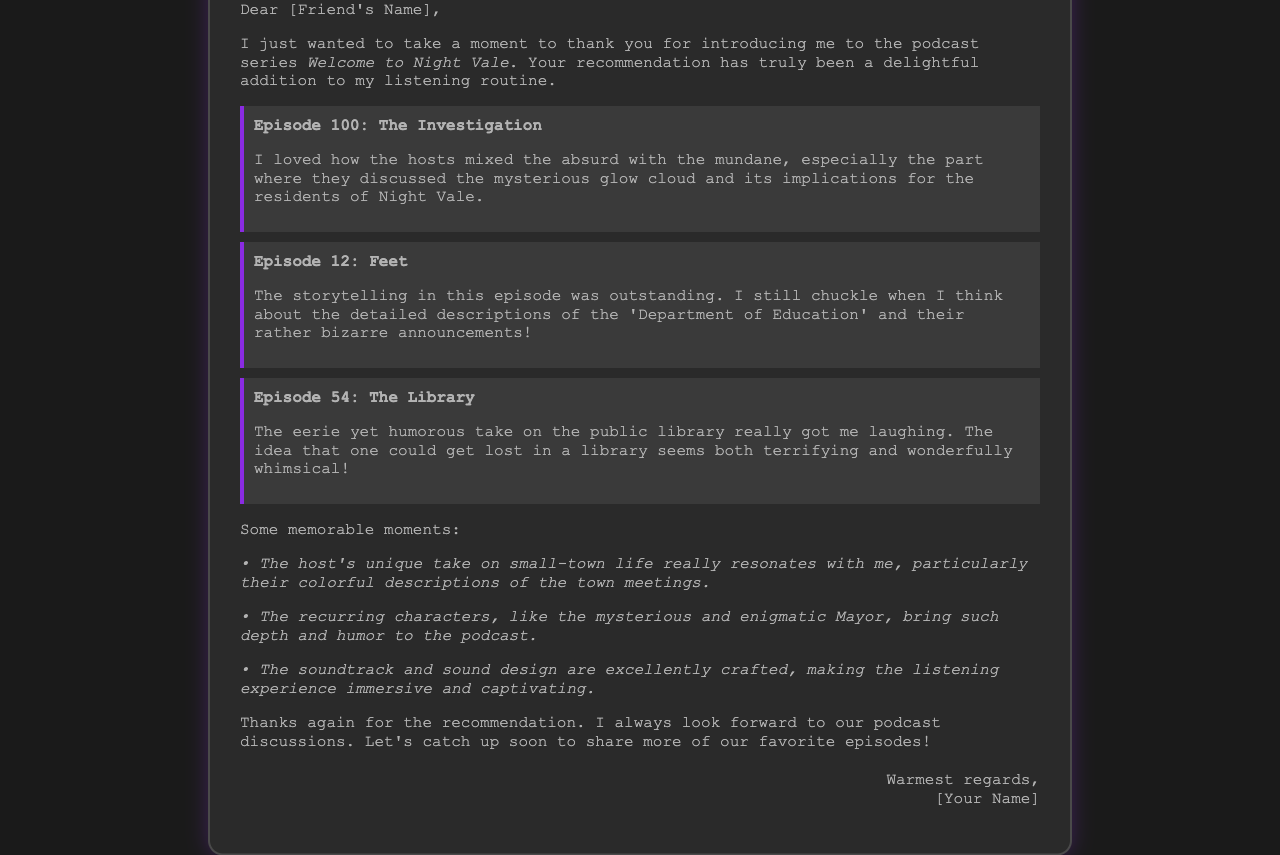what is the title of the podcast mentioned in the letter? The title of the podcast is provided in the opening paragraph of the letter.
Answer: Welcome to Night Vale who is the recipient of the thank-you note? The recipient's name is mentioned in the salutation of the letter, which is addressed to a friend.
Answer: [Friend's Name] which episode features "The Investigation"? The letter highlights various episodes, including their titles, and specifies which episode features "The Investigation".
Answer: Episode 100 what humorous element is noted in Episode 12? The letter describes an entertaining aspect of the episode, focusing on a particular department's bizarre announcements.
Answer: Department of Education name one memorable character mentioned in the document. The document lists characters that add humor, specifically noting the enigmatic Mayor as one of them.
Answer: Mayor how does the author feel about the podcast discussions? The closing remarks indicate the author's positive feelings regarding their discussions with the friend about the podcast.
Answer: Always look forward what aspect of the sound design is highlighted? The author appreciates how the sound design enhances the listening experience, adding to the document's immersive quality.
Answer: Excellently crafted what is the overall tone of the thank-you note? The language used throughout the letter provides insight into the author's feelings and attitude towards the podcast and the friend.
Answer: Charming how does the author describe getting lost in a library? The author presents a whimsical view of getting lost in a library, showing the humor intertwined with the setting.
Answer: Terrifying and wonderfully whimsical 